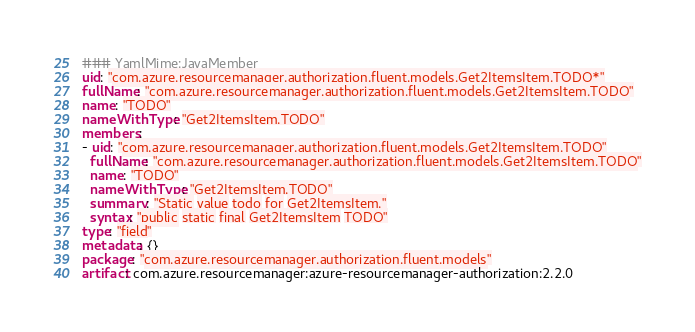Convert code to text. <code><loc_0><loc_0><loc_500><loc_500><_YAML_>### YamlMime:JavaMember
uid: "com.azure.resourcemanager.authorization.fluent.models.Get2ItemsItem.TODO*"
fullName: "com.azure.resourcemanager.authorization.fluent.models.Get2ItemsItem.TODO"
name: "TODO"
nameWithType: "Get2ItemsItem.TODO"
members:
- uid: "com.azure.resourcemanager.authorization.fluent.models.Get2ItemsItem.TODO"
  fullName: "com.azure.resourcemanager.authorization.fluent.models.Get2ItemsItem.TODO"
  name: "TODO"
  nameWithType: "Get2ItemsItem.TODO"
  summary: "Static value todo for Get2ItemsItem."
  syntax: "public static final Get2ItemsItem TODO"
type: "field"
metadata: {}
package: "com.azure.resourcemanager.authorization.fluent.models"
artifact: com.azure.resourcemanager:azure-resourcemanager-authorization:2.2.0
</code> 